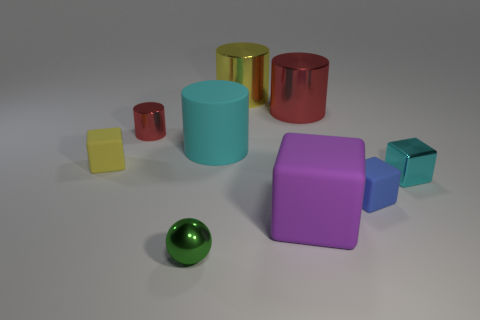How many shiny things are the same color as the tiny cylinder?
Your answer should be very brief. 1. What number of tiny objects are either rubber cubes or yellow objects?
Make the answer very short. 2. What is the shape of the tiny blue rubber object?
Give a very brief answer. Cube. What is the size of the object that is the same color as the small shiny block?
Your response must be concise. Large. Is there a small cylinder made of the same material as the cyan cube?
Your response must be concise. Yes. Is the number of tiny red shiny objects greater than the number of cylinders?
Make the answer very short. No. Do the tiny cyan thing and the green thing have the same material?
Keep it short and to the point. Yes. How many metallic objects are small purple objects or large cyan objects?
Provide a short and direct response. 0. What is the color of the ball that is the same size as the blue rubber thing?
Give a very brief answer. Green. How many other tiny rubber objects are the same shape as the yellow rubber object?
Offer a very short reply. 1. 